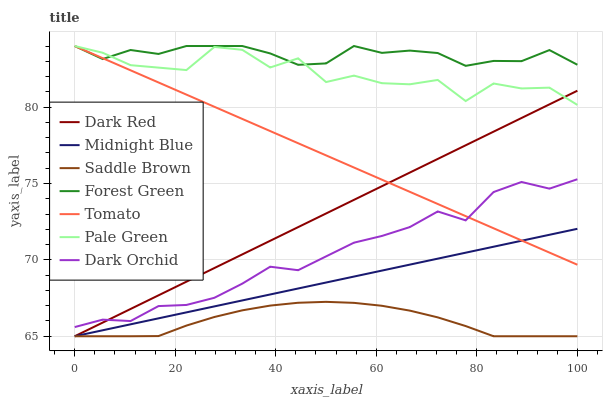Does Saddle Brown have the minimum area under the curve?
Answer yes or no. Yes. Does Forest Green have the maximum area under the curve?
Answer yes or no. Yes. Does Midnight Blue have the minimum area under the curve?
Answer yes or no. No. Does Midnight Blue have the maximum area under the curve?
Answer yes or no. No. Is Dark Red the smoothest?
Answer yes or no. Yes. Is Pale Green the roughest?
Answer yes or no. Yes. Is Midnight Blue the smoothest?
Answer yes or no. No. Is Midnight Blue the roughest?
Answer yes or no. No. Does Midnight Blue have the lowest value?
Answer yes or no. Yes. Does Dark Orchid have the lowest value?
Answer yes or no. No. Does Forest Green have the highest value?
Answer yes or no. Yes. Does Midnight Blue have the highest value?
Answer yes or no. No. Is Midnight Blue less than Forest Green?
Answer yes or no. Yes. Is Forest Green greater than Dark Red?
Answer yes or no. Yes. Does Dark Red intersect Midnight Blue?
Answer yes or no. Yes. Is Dark Red less than Midnight Blue?
Answer yes or no. No. Is Dark Red greater than Midnight Blue?
Answer yes or no. No. Does Midnight Blue intersect Forest Green?
Answer yes or no. No. 